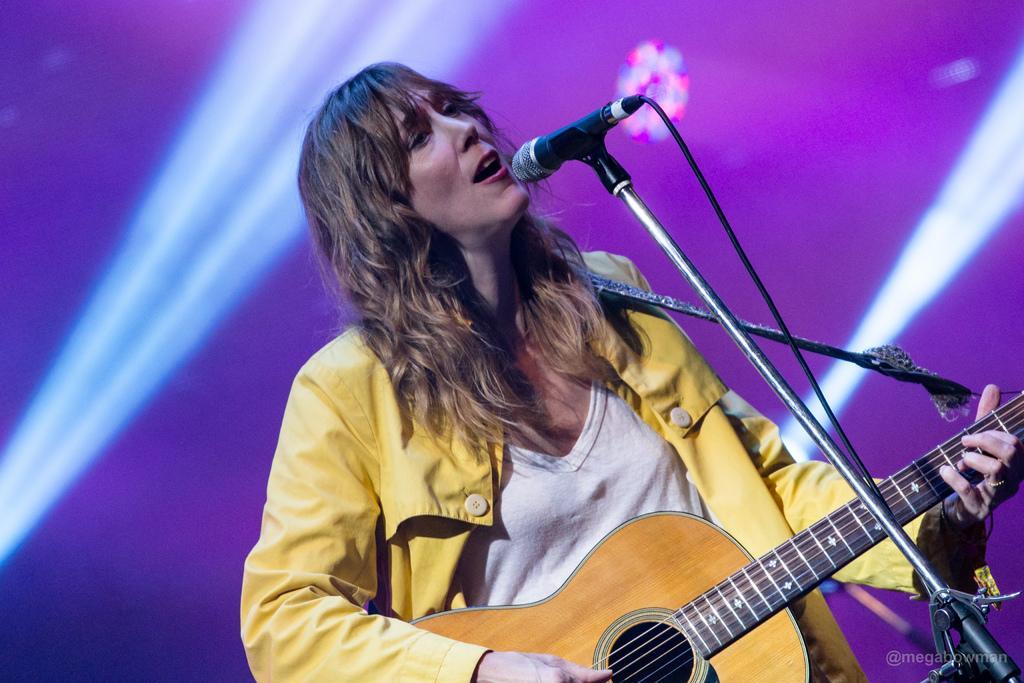Can you describe this image briefly? In this image there is a person who is wearing yellow color dress playing guitar in front of her there is a microphone. 